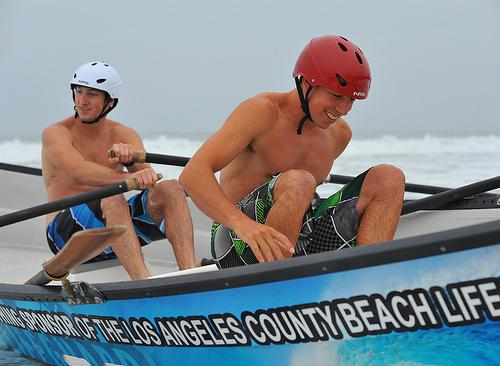What can be observed about the weather or natural conditions in the image? The sky appears to be grey, and there are ocean waves rolling in. What type of safety gear are the two boys in the image wearing? The two boys are wearing safety helmets, one with a red and black color and the other with a white and black color. List five objects that can be seen in the image. Two boys rowing a boat, red helmet on a boy, white helmet on a boy, blue and black swim trunks, green black and white swim trunks. What are the two boys in the image doing? The two boys are rowing a boat together, with one boy smiling and both wearing safety helmets. What color are the helmets worn by the two boys in the image? One boy is wearing a red helmet, and the other boy is wearing a white helmet. What is written on the side of the boat in the image? Words like "Los Angeles," "sponsor," "beach," and "life" are written on the side of the boat. In the image, how many paddles can be seen and what is a specific detail about one of them? There are two paddles in the image. One paddle has a brown handle and is not being touched at the moment. Which objects are the two boys using to complete their main activity in the image? The two boys are using boat oars or paddles to row the boat. Provide a brief description of the clothing worn by the two boys in the image. One boy is wearing blue, black, and white swim trunks, and the other boy is wearing green, black, and white swim trunks. Choose the correct description of the scene: (A) Two boys playing basketball, (B) Two boys rowing a boat, (C) Two boys riding bikes (B) Two boys rowing a boat Describe the different types of swim trunks the boys are wearing. One is wearing green, black, and white trunks; the other is wearing blue, black, and white trunks. Which of the boys is not wearing a shirt? (A) The boy in the red helmet, (B) The boy in the white helmet, (C) Neither of them. (C) Neither of them What is the environment surrounding the boat? Ocean waves, grey sky What material is the handle of the paddle made of? Wood Where will the waves on side of boaters eventually roll towards? The boat. Which boy is wearing the red helmet, and which boy is wearing the white helmet? The front boater wears the red helmet, while the back boater wears the white helmet. How many oars are visible in the image? Two Is the boy wearing the red helmet sitting in the back of the boat? The boy wearing the red helmet is actually sitting in the front of the boat. Is there a yellow helmet on one of the boys? There are no yellow helmets in the image, only red and white helmets are present. Do the two boys have any shirts on, and if so, what kind? No, they are both shirtless. Are the sky and ocean in the background pink and purple? The sky and ocean in the background are not pink and purple. The sky is grey and the ocean is a blueish-grey color. Does the boat have purple and orange stripes on its side? There are no stripes on the boat's side, only blue, white, and black colors are present. Identify the text written on the boat. Los Angeles, Sponsor, Beach, Life What is noticeable about the oar that is not being used at the moment? It's sticking out from the boat. What are the two boys doing in the image? Rowing a boat Describe the color and type of helmets the boys are wearing. One is wearing a red and black safety helmet, and the other is wearing a white and black safety helmet. Count the number of objects contained in the boat, excluding the boys. Three objects – two oars and a paddle. In the image, what is the position of the hand holding the handle of the oar? Right hand of the young man in front. What are the colors of the boat in the image? Blue, white, and black Are both boys' swimming trunks entirely black? Neither of the boys' swimming trunks are entirely black. One pair is green, black, and white, while the other pair is blue, black, and white. The smile on the boy's face indicates his... Happiness What do the white letters with a black border on the boat signify? Sponsor names and information. Do the white words on the boat say "New York"? The white words on the boat actually say "Los Angeles", not "New York". State the colors and patterns of the helmets worn by the two boys. One red and black, the other white and black.  